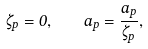Convert formula to latex. <formula><loc_0><loc_0><loc_500><loc_500>\dot { \zeta } _ { p } = 0 , \quad \dot { a } _ { p } = \frac { a _ { p } } { \zeta _ { p } } ,</formula> 